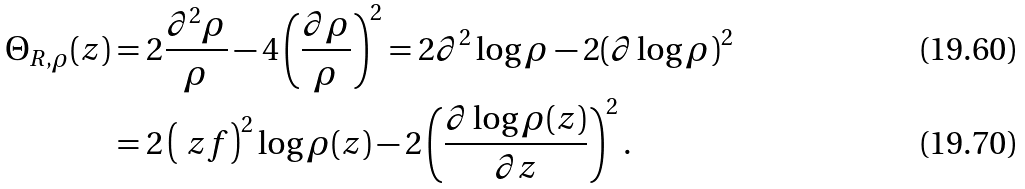<formula> <loc_0><loc_0><loc_500><loc_500>\Theta _ { R , \rho } ( z ) & = 2 \frac { \partial ^ { 2 } \rho } { \rho } - 4 \left ( \frac { \partial \rho } { \rho } \right ) ^ { 2 } = 2 \partial ^ { 2 } \log \rho - 2 ( \partial \log \rho ) ^ { 2 } \\ & = 2 \left ( \ z f \right ) ^ { 2 } \log \rho ( z ) - 2 \left ( \frac { \partial \log \rho ( z ) } { \partial z } \right ) ^ { 2 } .</formula> 